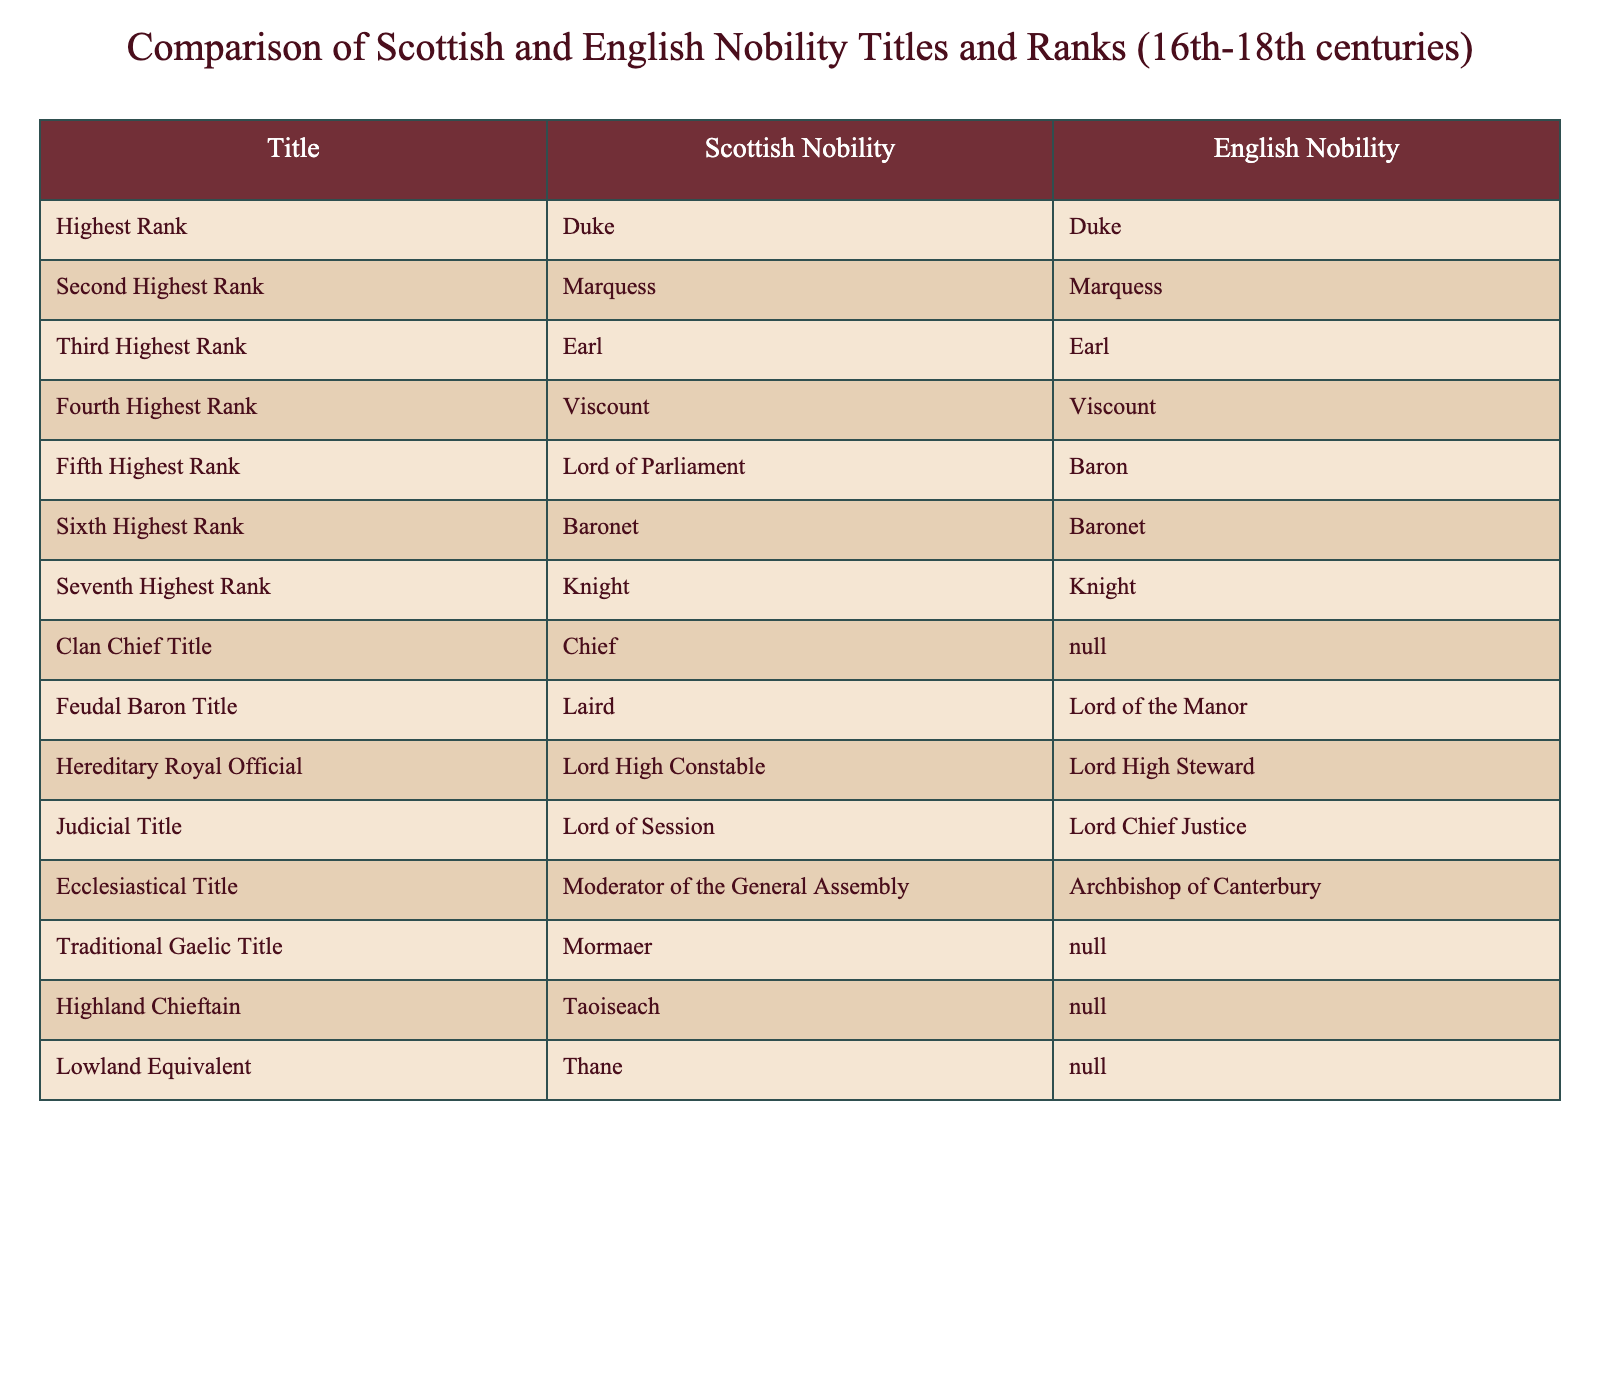What is the highest rank in both Scottish and English nobility? The highest rank listed for both Scottish and English nobility in the table is "Duke."
Answer: Duke Which title is equivalent to "Earl" in both Scottish and English nobility? The title "Earl" is the same in both Scottish and English nobility, as indicated in the table.
Answer: Earl Does Scottish nobility have a title equivalent to "Chief"? According to the table, the Scottish nobility has a specific title "Chief" that does not have an equivalent in English nobility.
Answer: Yes How many ranks are there in Scottish nobility up to "Baronet"? In the table, Scottish nobility lists six ranks up to "Baronet." These include Duke, Marquess, Earl, Viscount, Lord of Parliament, and Baronet.
Answer: 6 Is "Lord of Parliament" a title recognized in English nobility? The table shows that "Lord of Parliament" is a distinct title in Scottish nobility, while the equivalent rank in English nobility is "Baron." Thus, it's not recognized.
Answer: No What is the traditional Gaelic title listed for Scottish nobility? The table specifies that the traditional Gaelic title for Scottish nobility is "Mormaer."
Answer: Mormaer Which Scottish title does not have a counterpart in English nobility? The titles "Chief," "Mormaer," "Taoiseach," and "Thane" are all exclusive to Scottish nobility without English counterparts, as noted in the table.
Answer: Chief, Mormaer, Taoiseach, Thane Which rank comes immediately below "Duke" in both Scottish and English nobility? Following "Duke," the next title listed for both Scottish and English nobility is "Marquess."
Answer: Marquess What is the difference in the titles for the feudal baron between Scottish and English nobility? The table indicates that in Scottish nobility, the title is "Laird," while in English nobility, it is "Lord of the Manor."
Answer: Laird vs. Lord of the Manor List all titles that have the same name in both Scottish and English nobility. The table reveals that the titles which share the same name in both Scottish and English nobility are Duke, Marquess, Earl, Viscount, and Knight.
Answer: Duke, Marquess, Earl, Viscount, Knight 